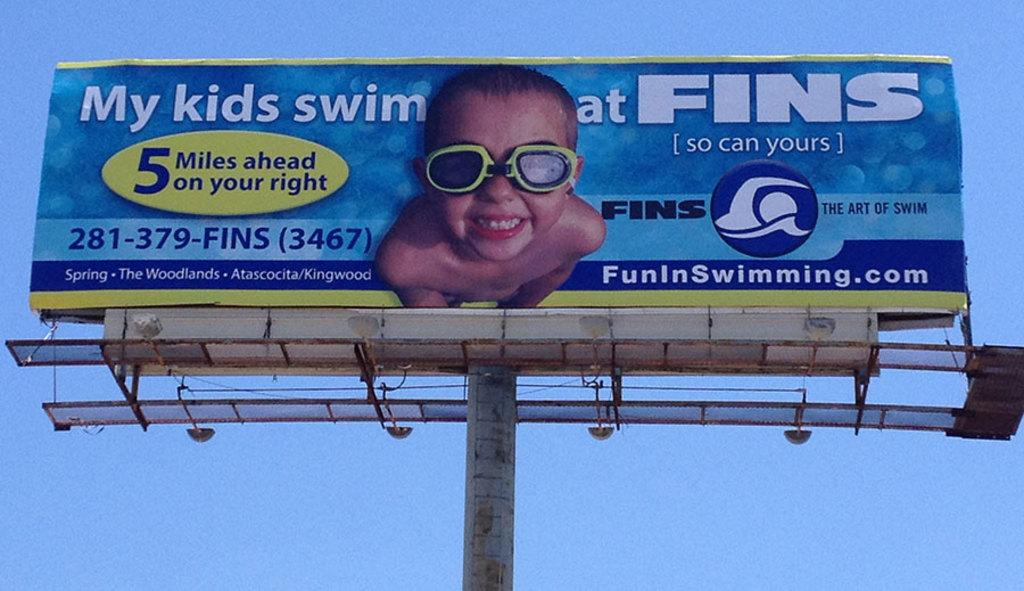<image>
Share a concise interpretation of the image provided. A bilboard for FINS that says "My kids swim at FINS, so can yours" 